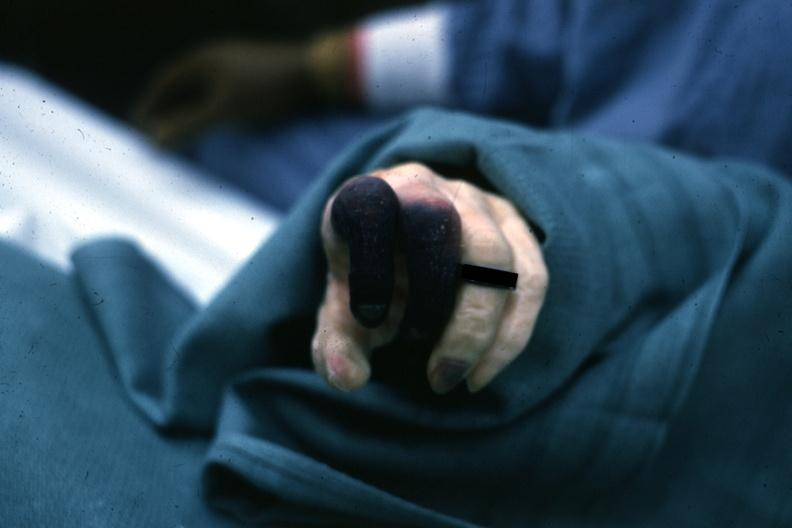what does this image show?
Answer the question using a single word or phrase. Excellent example gangrene first 